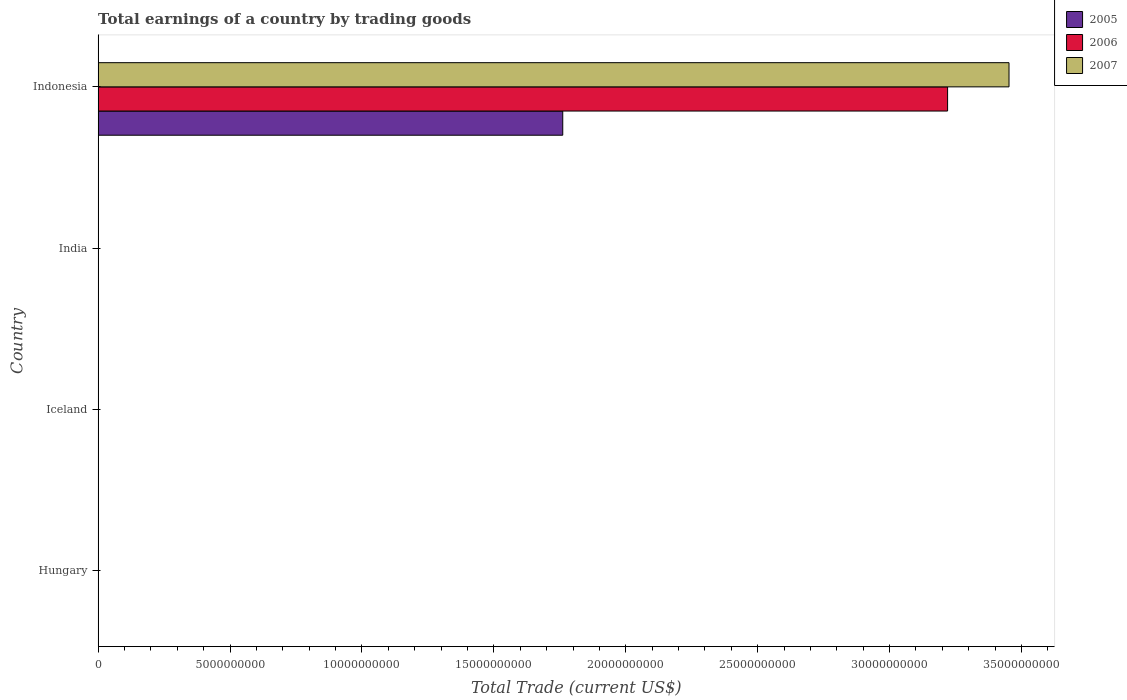Are the number of bars on each tick of the Y-axis equal?
Offer a terse response. No. How many bars are there on the 3rd tick from the top?
Give a very brief answer. 0. How many bars are there on the 1st tick from the bottom?
Ensure brevity in your answer.  0. What is the label of the 3rd group of bars from the top?
Ensure brevity in your answer.  Iceland. In how many cases, is the number of bars for a given country not equal to the number of legend labels?
Give a very brief answer. 3. What is the total earnings in 2007 in Indonesia?
Your response must be concise. 3.45e+1. Across all countries, what is the maximum total earnings in 2006?
Provide a succinct answer. 3.22e+1. What is the total total earnings in 2006 in the graph?
Give a very brief answer. 3.22e+1. What is the difference between the total earnings in 2007 in Indonesia and the total earnings in 2006 in Hungary?
Your response must be concise. 3.45e+1. What is the average total earnings in 2007 per country?
Your answer should be very brief. 8.63e+09. What is the difference between the total earnings in 2006 and total earnings in 2005 in Indonesia?
Your answer should be compact. 1.46e+1. What is the difference between the highest and the lowest total earnings in 2007?
Ensure brevity in your answer.  3.45e+1. In how many countries, is the total earnings in 2007 greater than the average total earnings in 2007 taken over all countries?
Offer a terse response. 1. Is it the case that in every country, the sum of the total earnings in 2005 and total earnings in 2006 is greater than the total earnings in 2007?
Your response must be concise. No. How many bars are there?
Keep it short and to the point. 3. Are all the bars in the graph horizontal?
Make the answer very short. Yes. How many countries are there in the graph?
Keep it short and to the point. 4. Does the graph contain any zero values?
Provide a short and direct response. Yes. How many legend labels are there?
Offer a very short reply. 3. How are the legend labels stacked?
Ensure brevity in your answer.  Vertical. What is the title of the graph?
Offer a terse response. Total earnings of a country by trading goods. Does "1977" appear as one of the legend labels in the graph?
Make the answer very short. No. What is the label or title of the X-axis?
Provide a succinct answer. Total Trade (current US$). What is the label or title of the Y-axis?
Offer a very short reply. Country. What is the Total Trade (current US$) in 2005 in Hungary?
Your response must be concise. 0. What is the Total Trade (current US$) in 2005 in India?
Ensure brevity in your answer.  0. What is the Total Trade (current US$) of 2005 in Indonesia?
Your answer should be very brief. 1.76e+1. What is the Total Trade (current US$) of 2006 in Indonesia?
Your answer should be compact. 3.22e+1. What is the Total Trade (current US$) of 2007 in Indonesia?
Your response must be concise. 3.45e+1. Across all countries, what is the maximum Total Trade (current US$) in 2005?
Provide a succinct answer. 1.76e+1. Across all countries, what is the maximum Total Trade (current US$) in 2006?
Provide a succinct answer. 3.22e+1. Across all countries, what is the maximum Total Trade (current US$) of 2007?
Your answer should be compact. 3.45e+1. Across all countries, what is the minimum Total Trade (current US$) of 2005?
Your answer should be very brief. 0. Across all countries, what is the minimum Total Trade (current US$) in 2006?
Provide a short and direct response. 0. Across all countries, what is the minimum Total Trade (current US$) of 2007?
Your answer should be compact. 0. What is the total Total Trade (current US$) in 2005 in the graph?
Give a very brief answer. 1.76e+1. What is the total Total Trade (current US$) of 2006 in the graph?
Provide a short and direct response. 3.22e+1. What is the total Total Trade (current US$) in 2007 in the graph?
Your response must be concise. 3.45e+1. What is the average Total Trade (current US$) in 2005 per country?
Your answer should be compact. 4.40e+09. What is the average Total Trade (current US$) of 2006 per country?
Offer a very short reply. 8.05e+09. What is the average Total Trade (current US$) of 2007 per country?
Your answer should be compact. 8.63e+09. What is the difference between the Total Trade (current US$) of 2005 and Total Trade (current US$) of 2006 in Indonesia?
Provide a succinct answer. -1.46e+1. What is the difference between the Total Trade (current US$) of 2005 and Total Trade (current US$) of 2007 in Indonesia?
Offer a terse response. -1.69e+1. What is the difference between the Total Trade (current US$) in 2006 and Total Trade (current US$) in 2007 in Indonesia?
Offer a terse response. -2.33e+09. What is the difference between the highest and the lowest Total Trade (current US$) of 2005?
Offer a terse response. 1.76e+1. What is the difference between the highest and the lowest Total Trade (current US$) of 2006?
Offer a very short reply. 3.22e+1. What is the difference between the highest and the lowest Total Trade (current US$) of 2007?
Make the answer very short. 3.45e+1. 